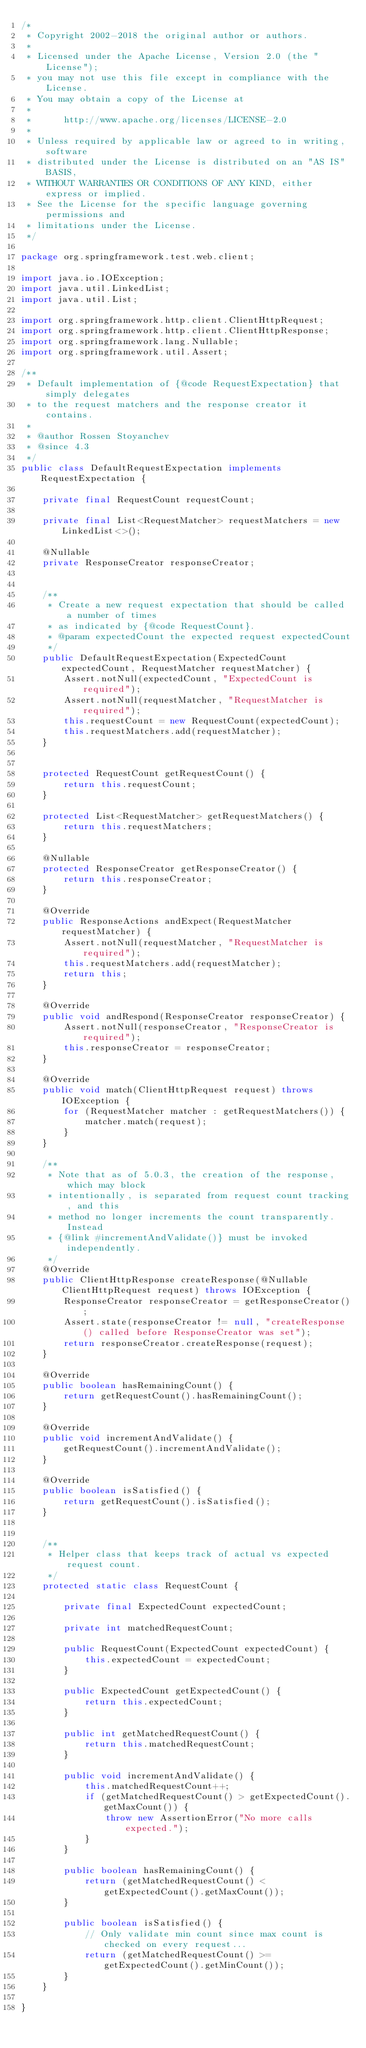<code> <loc_0><loc_0><loc_500><loc_500><_Java_>/*
 * Copyright 2002-2018 the original author or authors.
 *
 * Licensed under the Apache License, Version 2.0 (the "License");
 * you may not use this file except in compliance with the License.
 * You may obtain a copy of the License at
 *
 *      http://www.apache.org/licenses/LICENSE-2.0
 *
 * Unless required by applicable law or agreed to in writing, software
 * distributed under the License is distributed on an "AS IS" BASIS,
 * WITHOUT WARRANTIES OR CONDITIONS OF ANY KIND, either express or implied.
 * See the License for the specific language governing permissions and
 * limitations under the License.
 */

package org.springframework.test.web.client;

import java.io.IOException;
import java.util.LinkedList;
import java.util.List;

import org.springframework.http.client.ClientHttpRequest;
import org.springframework.http.client.ClientHttpResponse;
import org.springframework.lang.Nullable;
import org.springframework.util.Assert;

/**
 * Default implementation of {@code RequestExpectation} that simply delegates
 * to the request matchers and the response creator it contains.
 *
 * @author Rossen Stoyanchev
 * @since 4.3
 */
public class DefaultRequestExpectation implements RequestExpectation {

	private final RequestCount requestCount;

	private final List<RequestMatcher> requestMatchers = new LinkedList<>();

	@Nullable
	private ResponseCreator responseCreator;


	/**
	 * Create a new request expectation that should be called a number of times
	 * as indicated by {@code RequestCount}.
	 * @param expectedCount the expected request expectedCount
	 */
	public DefaultRequestExpectation(ExpectedCount expectedCount, RequestMatcher requestMatcher) {
		Assert.notNull(expectedCount, "ExpectedCount is required");
		Assert.notNull(requestMatcher, "RequestMatcher is required");
		this.requestCount = new RequestCount(expectedCount);
		this.requestMatchers.add(requestMatcher);
	}


	protected RequestCount getRequestCount() {
		return this.requestCount;
	}

	protected List<RequestMatcher> getRequestMatchers() {
		return this.requestMatchers;
	}

	@Nullable
	protected ResponseCreator getResponseCreator() {
		return this.responseCreator;
	}

	@Override
	public ResponseActions andExpect(RequestMatcher requestMatcher) {
		Assert.notNull(requestMatcher, "RequestMatcher is required");
		this.requestMatchers.add(requestMatcher);
		return this;
	}

	@Override
	public void andRespond(ResponseCreator responseCreator) {
		Assert.notNull(responseCreator, "ResponseCreator is required");
		this.responseCreator = responseCreator;
	}

	@Override
	public void match(ClientHttpRequest request) throws IOException {
		for (RequestMatcher matcher : getRequestMatchers()) {
			matcher.match(request);
		}
	}

	/**
	 * Note that as of 5.0.3, the creation of the response, which may block
	 * intentionally, is separated from request count tracking, and this
	 * method no longer increments the count transparently. Instead
	 * {@link #incrementAndValidate()} must be invoked independently.
	 */
	@Override
	public ClientHttpResponse createResponse(@Nullable ClientHttpRequest request) throws IOException {
		ResponseCreator responseCreator = getResponseCreator();
		Assert.state(responseCreator != null, "createResponse() called before ResponseCreator was set");
		return responseCreator.createResponse(request);
	}

	@Override
	public boolean hasRemainingCount() {
		return getRequestCount().hasRemainingCount();
	}

	@Override
	public void incrementAndValidate() {
		getRequestCount().incrementAndValidate();
	}

	@Override
	public boolean isSatisfied() {
		return getRequestCount().isSatisfied();
	}


	/**
	 * Helper class that keeps track of actual vs expected request count.
	 */
	protected static class RequestCount {

		private final ExpectedCount expectedCount;

		private int matchedRequestCount;

		public RequestCount(ExpectedCount expectedCount) {
			this.expectedCount = expectedCount;
		}

		public ExpectedCount getExpectedCount() {
			return this.expectedCount;
		}

		public int getMatchedRequestCount() {
			return this.matchedRequestCount;
		}

		public void incrementAndValidate() {
			this.matchedRequestCount++;
			if (getMatchedRequestCount() > getExpectedCount().getMaxCount()) {
				throw new AssertionError("No more calls expected.");
			}
		}

		public boolean hasRemainingCount() {
			return (getMatchedRequestCount() < getExpectedCount().getMaxCount());
		}

		public boolean isSatisfied() {
			// Only validate min count since max count is checked on every request...
			return (getMatchedRequestCount() >= getExpectedCount().getMinCount());
		}
	}

}
</code> 